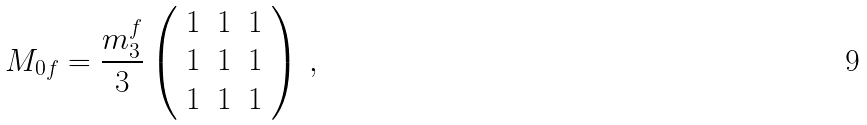Convert formula to latex. <formula><loc_0><loc_0><loc_500><loc_500>M _ { 0 f } = \frac { m _ { 3 } ^ { f } } { 3 } \left ( \begin{array} { c c c } 1 & 1 & 1 \\ 1 & 1 & 1 \\ 1 & 1 & 1 \end{array} \right ) \, ,</formula> 